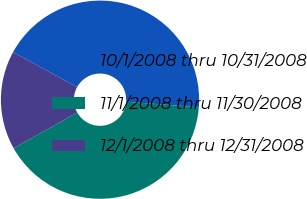<chart> <loc_0><loc_0><loc_500><loc_500><pie_chart><fcel>10/1/2008 thru 10/31/2008<fcel>11/1/2008 thru 11/30/2008<fcel>12/1/2008 thru 12/31/2008<nl><fcel>43.26%<fcel>40.62%<fcel>16.12%<nl></chart> 